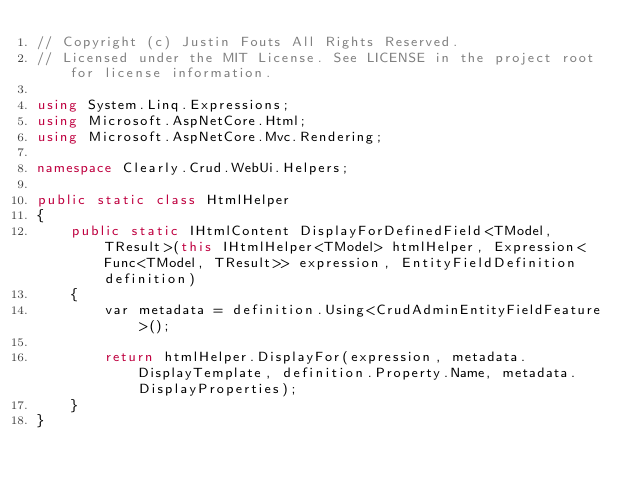Convert code to text. <code><loc_0><loc_0><loc_500><loc_500><_C#_>// Copyright (c) Justin Fouts All Rights Reserved.
// Licensed under the MIT License. See LICENSE in the project root for license information.

using System.Linq.Expressions;
using Microsoft.AspNetCore.Html;
using Microsoft.AspNetCore.Mvc.Rendering;

namespace Clearly.Crud.WebUi.Helpers;

public static class HtmlHelper
{
    public static IHtmlContent DisplayForDefinedField<TModel, TResult>(this IHtmlHelper<TModel> htmlHelper, Expression<Func<TModel, TResult>> expression, EntityFieldDefinition definition)
    {
        var metadata = definition.Using<CrudAdminEntityFieldFeature>();

        return htmlHelper.DisplayFor(expression, metadata.DisplayTemplate, definition.Property.Name, metadata.DisplayProperties);
    }
}
</code> 